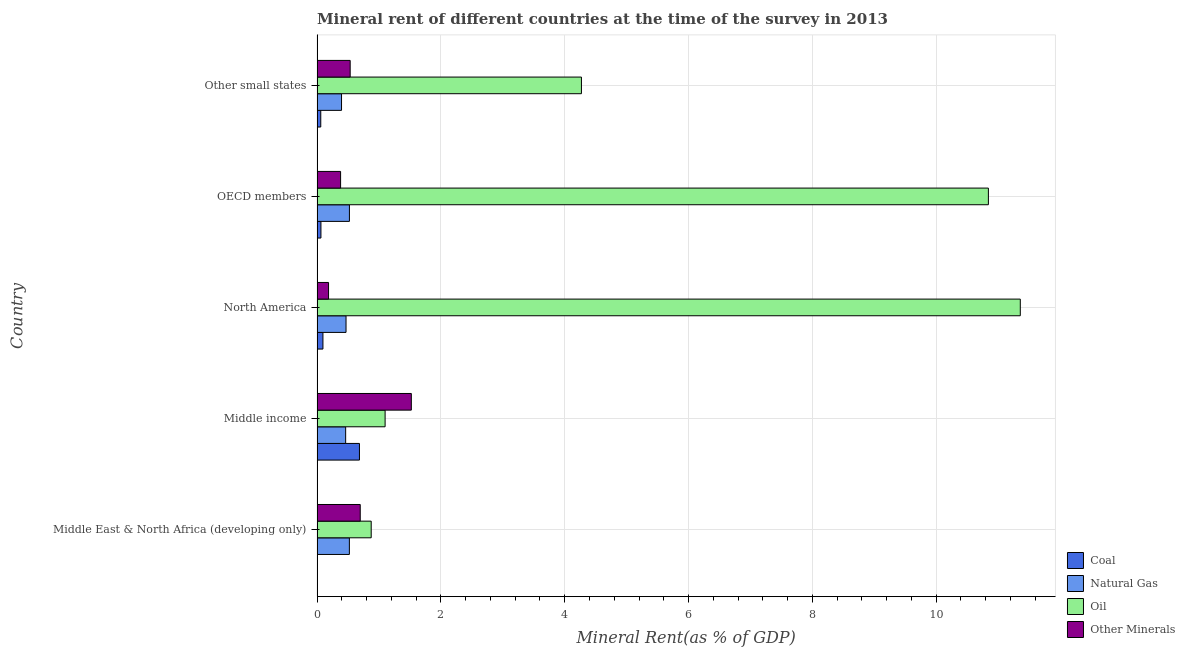How many groups of bars are there?
Ensure brevity in your answer.  5. How many bars are there on the 1st tick from the top?
Offer a terse response. 4. In how many cases, is the number of bars for a given country not equal to the number of legend labels?
Your answer should be compact. 0. What is the coal rent in North America?
Give a very brief answer. 0.09. Across all countries, what is the maximum oil rent?
Give a very brief answer. 11.36. Across all countries, what is the minimum  rent of other minerals?
Provide a short and direct response. 0.19. In which country was the oil rent maximum?
Offer a terse response. North America. In which country was the oil rent minimum?
Your answer should be very brief. Middle East & North Africa (developing only). What is the total natural gas rent in the graph?
Your response must be concise. 2.37. What is the difference between the  rent of other minerals in Middle East & North Africa (developing only) and that in North America?
Provide a short and direct response. 0.51. What is the difference between the oil rent in Middle income and the coal rent in OECD members?
Your response must be concise. 1.04. What is the average  rent of other minerals per country?
Offer a terse response. 0.66. What is the difference between the natural gas rent and oil rent in Middle income?
Keep it short and to the point. -0.64. In how many countries, is the oil rent greater than 4.8 %?
Your answer should be compact. 2. What is the ratio of the oil rent in North America to that in Other small states?
Provide a short and direct response. 2.66. Is the coal rent in Middle East & North Africa (developing only) less than that in OECD members?
Your answer should be compact. Yes. What is the difference between the highest and the second highest oil rent?
Your response must be concise. 0.52. What is the difference between the highest and the lowest  rent of other minerals?
Offer a terse response. 1.34. Is it the case that in every country, the sum of the coal rent and  rent of other minerals is greater than the sum of oil rent and natural gas rent?
Ensure brevity in your answer.  No. What does the 3rd bar from the top in Other small states represents?
Ensure brevity in your answer.  Natural Gas. What does the 2nd bar from the bottom in Other small states represents?
Offer a terse response. Natural Gas. Is it the case that in every country, the sum of the coal rent and natural gas rent is greater than the oil rent?
Offer a very short reply. No. How many bars are there?
Provide a succinct answer. 20. Does the graph contain grids?
Offer a terse response. Yes. Where does the legend appear in the graph?
Offer a terse response. Bottom right. What is the title of the graph?
Your answer should be compact. Mineral rent of different countries at the time of the survey in 2013. What is the label or title of the X-axis?
Ensure brevity in your answer.  Mineral Rent(as % of GDP). What is the Mineral Rent(as % of GDP) of Coal in Middle East & North Africa (developing only)?
Ensure brevity in your answer.  0. What is the Mineral Rent(as % of GDP) in Natural Gas in Middle East & North Africa (developing only)?
Make the answer very short. 0.52. What is the Mineral Rent(as % of GDP) of Oil in Middle East & North Africa (developing only)?
Offer a very short reply. 0.87. What is the Mineral Rent(as % of GDP) of Other Minerals in Middle East & North Africa (developing only)?
Ensure brevity in your answer.  0.7. What is the Mineral Rent(as % of GDP) in Coal in Middle income?
Ensure brevity in your answer.  0.68. What is the Mineral Rent(as % of GDP) in Natural Gas in Middle income?
Offer a very short reply. 0.46. What is the Mineral Rent(as % of GDP) in Oil in Middle income?
Keep it short and to the point. 1.1. What is the Mineral Rent(as % of GDP) in Other Minerals in Middle income?
Offer a terse response. 1.52. What is the Mineral Rent(as % of GDP) of Coal in North America?
Make the answer very short. 0.09. What is the Mineral Rent(as % of GDP) of Natural Gas in North America?
Offer a very short reply. 0.47. What is the Mineral Rent(as % of GDP) in Oil in North America?
Make the answer very short. 11.36. What is the Mineral Rent(as % of GDP) in Other Minerals in North America?
Make the answer very short. 0.19. What is the Mineral Rent(as % of GDP) in Coal in OECD members?
Your answer should be compact. 0.06. What is the Mineral Rent(as % of GDP) in Natural Gas in OECD members?
Your response must be concise. 0.52. What is the Mineral Rent(as % of GDP) of Oil in OECD members?
Your answer should be very brief. 10.84. What is the Mineral Rent(as % of GDP) in Other Minerals in OECD members?
Offer a very short reply. 0.38. What is the Mineral Rent(as % of GDP) of Coal in Other small states?
Your answer should be very brief. 0.06. What is the Mineral Rent(as % of GDP) of Natural Gas in Other small states?
Provide a succinct answer. 0.4. What is the Mineral Rent(as % of GDP) in Oil in Other small states?
Provide a succinct answer. 4.27. What is the Mineral Rent(as % of GDP) in Other Minerals in Other small states?
Give a very brief answer. 0.54. Across all countries, what is the maximum Mineral Rent(as % of GDP) in Coal?
Your response must be concise. 0.68. Across all countries, what is the maximum Mineral Rent(as % of GDP) of Natural Gas?
Offer a very short reply. 0.52. Across all countries, what is the maximum Mineral Rent(as % of GDP) of Oil?
Keep it short and to the point. 11.36. Across all countries, what is the maximum Mineral Rent(as % of GDP) of Other Minerals?
Give a very brief answer. 1.52. Across all countries, what is the minimum Mineral Rent(as % of GDP) of Coal?
Provide a short and direct response. 0. Across all countries, what is the minimum Mineral Rent(as % of GDP) in Natural Gas?
Your answer should be compact. 0.4. Across all countries, what is the minimum Mineral Rent(as % of GDP) of Oil?
Your response must be concise. 0.87. Across all countries, what is the minimum Mineral Rent(as % of GDP) in Other Minerals?
Make the answer very short. 0.19. What is the total Mineral Rent(as % of GDP) in Coal in the graph?
Your response must be concise. 0.91. What is the total Mineral Rent(as % of GDP) in Natural Gas in the graph?
Your answer should be very brief. 2.37. What is the total Mineral Rent(as % of GDP) in Oil in the graph?
Ensure brevity in your answer.  28.45. What is the total Mineral Rent(as % of GDP) in Other Minerals in the graph?
Keep it short and to the point. 3.32. What is the difference between the Mineral Rent(as % of GDP) of Coal in Middle East & North Africa (developing only) and that in Middle income?
Offer a very short reply. -0.68. What is the difference between the Mineral Rent(as % of GDP) in Natural Gas in Middle East & North Africa (developing only) and that in Middle income?
Provide a short and direct response. 0.06. What is the difference between the Mineral Rent(as % of GDP) in Oil in Middle East & North Africa (developing only) and that in Middle income?
Offer a very short reply. -0.22. What is the difference between the Mineral Rent(as % of GDP) in Other Minerals in Middle East & North Africa (developing only) and that in Middle income?
Offer a terse response. -0.83. What is the difference between the Mineral Rent(as % of GDP) in Coal in Middle East & North Africa (developing only) and that in North America?
Offer a very short reply. -0.09. What is the difference between the Mineral Rent(as % of GDP) of Natural Gas in Middle East & North Africa (developing only) and that in North America?
Offer a terse response. 0.05. What is the difference between the Mineral Rent(as % of GDP) in Oil in Middle East & North Africa (developing only) and that in North America?
Give a very brief answer. -10.48. What is the difference between the Mineral Rent(as % of GDP) of Other Minerals in Middle East & North Africa (developing only) and that in North America?
Keep it short and to the point. 0.51. What is the difference between the Mineral Rent(as % of GDP) in Coal in Middle East & North Africa (developing only) and that in OECD members?
Make the answer very short. -0.06. What is the difference between the Mineral Rent(as % of GDP) of Natural Gas in Middle East & North Africa (developing only) and that in OECD members?
Make the answer very short. -0. What is the difference between the Mineral Rent(as % of GDP) in Oil in Middle East & North Africa (developing only) and that in OECD members?
Keep it short and to the point. -9.97. What is the difference between the Mineral Rent(as % of GDP) in Other Minerals in Middle East & North Africa (developing only) and that in OECD members?
Ensure brevity in your answer.  0.32. What is the difference between the Mineral Rent(as % of GDP) of Coal in Middle East & North Africa (developing only) and that in Other small states?
Your answer should be compact. -0.06. What is the difference between the Mineral Rent(as % of GDP) of Natural Gas in Middle East & North Africa (developing only) and that in Other small states?
Ensure brevity in your answer.  0.13. What is the difference between the Mineral Rent(as % of GDP) of Oil in Middle East & North Africa (developing only) and that in Other small states?
Offer a very short reply. -3.4. What is the difference between the Mineral Rent(as % of GDP) of Other Minerals in Middle East & North Africa (developing only) and that in Other small states?
Provide a short and direct response. 0.16. What is the difference between the Mineral Rent(as % of GDP) in Coal in Middle income and that in North America?
Your response must be concise. 0.59. What is the difference between the Mineral Rent(as % of GDP) of Natural Gas in Middle income and that in North America?
Keep it short and to the point. -0.01. What is the difference between the Mineral Rent(as % of GDP) of Oil in Middle income and that in North America?
Your answer should be compact. -10.26. What is the difference between the Mineral Rent(as % of GDP) in Other Minerals in Middle income and that in North America?
Offer a terse response. 1.34. What is the difference between the Mineral Rent(as % of GDP) in Coal in Middle income and that in OECD members?
Offer a terse response. 0.62. What is the difference between the Mineral Rent(as % of GDP) of Natural Gas in Middle income and that in OECD members?
Offer a very short reply. -0.06. What is the difference between the Mineral Rent(as % of GDP) of Oil in Middle income and that in OECD members?
Make the answer very short. -9.74. What is the difference between the Mineral Rent(as % of GDP) in Other Minerals in Middle income and that in OECD members?
Keep it short and to the point. 1.14. What is the difference between the Mineral Rent(as % of GDP) in Coal in Middle income and that in Other small states?
Your response must be concise. 0.62. What is the difference between the Mineral Rent(as % of GDP) in Natural Gas in Middle income and that in Other small states?
Keep it short and to the point. 0.07. What is the difference between the Mineral Rent(as % of GDP) in Oil in Middle income and that in Other small states?
Your answer should be very brief. -3.17. What is the difference between the Mineral Rent(as % of GDP) of Other Minerals in Middle income and that in Other small states?
Ensure brevity in your answer.  0.99. What is the difference between the Mineral Rent(as % of GDP) in Coal in North America and that in OECD members?
Offer a very short reply. 0.03. What is the difference between the Mineral Rent(as % of GDP) of Natural Gas in North America and that in OECD members?
Provide a succinct answer. -0.05. What is the difference between the Mineral Rent(as % of GDP) in Oil in North America and that in OECD members?
Provide a succinct answer. 0.52. What is the difference between the Mineral Rent(as % of GDP) of Other Minerals in North America and that in OECD members?
Keep it short and to the point. -0.19. What is the difference between the Mineral Rent(as % of GDP) in Coal in North America and that in Other small states?
Your response must be concise. 0.04. What is the difference between the Mineral Rent(as % of GDP) of Natural Gas in North America and that in Other small states?
Ensure brevity in your answer.  0.07. What is the difference between the Mineral Rent(as % of GDP) of Oil in North America and that in Other small states?
Give a very brief answer. 7.09. What is the difference between the Mineral Rent(as % of GDP) in Other Minerals in North America and that in Other small states?
Offer a very short reply. -0.35. What is the difference between the Mineral Rent(as % of GDP) of Coal in OECD members and that in Other small states?
Your response must be concise. 0. What is the difference between the Mineral Rent(as % of GDP) in Natural Gas in OECD members and that in Other small states?
Your answer should be very brief. 0.13. What is the difference between the Mineral Rent(as % of GDP) of Oil in OECD members and that in Other small states?
Give a very brief answer. 6.57. What is the difference between the Mineral Rent(as % of GDP) in Other Minerals in OECD members and that in Other small states?
Provide a succinct answer. -0.15. What is the difference between the Mineral Rent(as % of GDP) of Coal in Middle East & North Africa (developing only) and the Mineral Rent(as % of GDP) of Natural Gas in Middle income?
Ensure brevity in your answer.  -0.46. What is the difference between the Mineral Rent(as % of GDP) of Coal in Middle East & North Africa (developing only) and the Mineral Rent(as % of GDP) of Oil in Middle income?
Keep it short and to the point. -1.1. What is the difference between the Mineral Rent(as % of GDP) of Coal in Middle East & North Africa (developing only) and the Mineral Rent(as % of GDP) of Other Minerals in Middle income?
Provide a short and direct response. -1.52. What is the difference between the Mineral Rent(as % of GDP) in Natural Gas in Middle East & North Africa (developing only) and the Mineral Rent(as % of GDP) in Oil in Middle income?
Your answer should be compact. -0.58. What is the difference between the Mineral Rent(as % of GDP) of Natural Gas in Middle East & North Africa (developing only) and the Mineral Rent(as % of GDP) of Other Minerals in Middle income?
Ensure brevity in your answer.  -1. What is the difference between the Mineral Rent(as % of GDP) in Oil in Middle East & North Africa (developing only) and the Mineral Rent(as % of GDP) in Other Minerals in Middle income?
Your answer should be compact. -0.65. What is the difference between the Mineral Rent(as % of GDP) of Coal in Middle East & North Africa (developing only) and the Mineral Rent(as % of GDP) of Natural Gas in North America?
Your response must be concise. -0.46. What is the difference between the Mineral Rent(as % of GDP) in Coal in Middle East & North Africa (developing only) and the Mineral Rent(as % of GDP) in Oil in North America?
Your answer should be compact. -11.35. What is the difference between the Mineral Rent(as % of GDP) of Coal in Middle East & North Africa (developing only) and the Mineral Rent(as % of GDP) of Other Minerals in North America?
Give a very brief answer. -0.18. What is the difference between the Mineral Rent(as % of GDP) of Natural Gas in Middle East & North Africa (developing only) and the Mineral Rent(as % of GDP) of Oil in North America?
Offer a very short reply. -10.84. What is the difference between the Mineral Rent(as % of GDP) of Natural Gas in Middle East & North Africa (developing only) and the Mineral Rent(as % of GDP) of Other Minerals in North America?
Offer a terse response. 0.34. What is the difference between the Mineral Rent(as % of GDP) of Oil in Middle East & North Africa (developing only) and the Mineral Rent(as % of GDP) of Other Minerals in North America?
Make the answer very short. 0.69. What is the difference between the Mineral Rent(as % of GDP) of Coal in Middle East & North Africa (developing only) and the Mineral Rent(as % of GDP) of Natural Gas in OECD members?
Provide a succinct answer. -0.52. What is the difference between the Mineral Rent(as % of GDP) of Coal in Middle East & North Africa (developing only) and the Mineral Rent(as % of GDP) of Oil in OECD members?
Provide a succinct answer. -10.84. What is the difference between the Mineral Rent(as % of GDP) of Coal in Middle East & North Africa (developing only) and the Mineral Rent(as % of GDP) of Other Minerals in OECD members?
Provide a short and direct response. -0.38. What is the difference between the Mineral Rent(as % of GDP) in Natural Gas in Middle East & North Africa (developing only) and the Mineral Rent(as % of GDP) in Oil in OECD members?
Provide a succinct answer. -10.32. What is the difference between the Mineral Rent(as % of GDP) in Natural Gas in Middle East & North Africa (developing only) and the Mineral Rent(as % of GDP) in Other Minerals in OECD members?
Offer a very short reply. 0.14. What is the difference between the Mineral Rent(as % of GDP) of Oil in Middle East & North Africa (developing only) and the Mineral Rent(as % of GDP) of Other Minerals in OECD members?
Offer a very short reply. 0.49. What is the difference between the Mineral Rent(as % of GDP) of Coal in Middle East & North Africa (developing only) and the Mineral Rent(as % of GDP) of Natural Gas in Other small states?
Your answer should be compact. -0.39. What is the difference between the Mineral Rent(as % of GDP) of Coal in Middle East & North Africa (developing only) and the Mineral Rent(as % of GDP) of Oil in Other small states?
Ensure brevity in your answer.  -4.27. What is the difference between the Mineral Rent(as % of GDP) in Coal in Middle East & North Africa (developing only) and the Mineral Rent(as % of GDP) in Other Minerals in Other small states?
Keep it short and to the point. -0.53. What is the difference between the Mineral Rent(as % of GDP) of Natural Gas in Middle East & North Africa (developing only) and the Mineral Rent(as % of GDP) of Oil in Other small states?
Your answer should be compact. -3.75. What is the difference between the Mineral Rent(as % of GDP) of Natural Gas in Middle East & North Africa (developing only) and the Mineral Rent(as % of GDP) of Other Minerals in Other small states?
Offer a terse response. -0.01. What is the difference between the Mineral Rent(as % of GDP) in Oil in Middle East & North Africa (developing only) and the Mineral Rent(as % of GDP) in Other Minerals in Other small states?
Offer a terse response. 0.34. What is the difference between the Mineral Rent(as % of GDP) in Coal in Middle income and the Mineral Rent(as % of GDP) in Natural Gas in North America?
Your answer should be compact. 0.22. What is the difference between the Mineral Rent(as % of GDP) in Coal in Middle income and the Mineral Rent(as % of GDP) in Oil in North America?
Provide a short and direct response. -10.67. What is the difference between the Mineral Rent(as % of GDP) of Coal in Middle income and the Mineral Rent(as % of GDP) of Other Minerals in North America?
Make the answer very short. 0.5. What is the difference between the Mineral Rent(as % of GDP) of Natural Gas in Middle income and the Mineral Rent(as % of GDP) of Oil in North America?
Offer a terse response. -10.9. What is the difference between the Mineral Rent(as % of GDP) of Natural Gas in Middle income and the Mineral Rent(as % of GDP) of Other Minerals in North America?
Provide a short and direct response. 0.28. What is the difference between the Mineral Rent(as % of GDP) in Oil in Middle income and the Mineral Rent(as % of GDP) in Other Minerals in North America?
Provide a short and direct response. 0.91. What is the difference between the Mineral Rent(as % of GDP) in Coal in Middle income and the Mineral Rent(as % of GDP) in Natural Gas in OECD members?
Provide a short and direct response. 0.16. What is the difference between the Mineral Rent(as % of GDP) in Coal in Middle income and the Mineral Rent(as % of GDP) in Oil in OECD members?
Give a very brief answer. -10.16. What is the difference between the Mineral Rent(as % of GDP) in Coal in Middle income and the Mineral Rent(as % of GDP) in Other Minerals in OECD members?
Give a very brief answer. 0.3. What is the difference between the Mineral Rent(as % of GDP) of Natural Gas in Middle income and the Mineral Rent(as % of GDP) of Oil in OECD members?
Ensure brevity in your answer.  -10.38. What is the difference between the Mineral Rent(as % of GDP) of Natural Gas in Middle income and the Mineral Rent(as % of GDP) of Other Minerals in OECD members?
Provide a short and direct response. 0.08. What is the difference between the Mineral Rent(as % of GDP) of Oil in Middle income and the Mineral Rent(as % of GDP) of Other Minerals in OECD members?
Give a very brief answer. 0.72. What is the difference between the Mineral Rent(as % of GDP) of Coal in Middle income and the Mineral Rent(as % of GDP) of Natural Gas in Other small states?
Provide a short and direct response. 0.29. What is the difference between the Mineral Rent(as % of GDP) of Coal in Middle income and the Mineral Rent(as % of GDP) of Oil in Other small states?
Offer a terse response. -3.59. What is the difference between the Mineral Rent(as % of GDP) in Coal in Middle income and the Mineral Rent(as % of GDP) in Other Minerals in Other small states?
Offer a very short reply. 0.15. What is the difference between the Mineral Rent(as % of GDP) in Natural Gas in Middle income and the Mineral Rent(as % of GDP) in Oil in Other small states?
Your answer should be very brief. -3.81. What is the difference between the Mineral Rent(as % of GDP) of Natural Gas in Middle income and the Mineral Rent(as % of GDP) of Other Minerals in Other small states?
Your response must be concise. -0.07. What is the difference between the Mineral Rent(as % of GDP) in Oil in Middle income and the Mineral Rent(as % of GDP) in Other Minerals in Other small states?
Offer a terse response. 0.56. What is the difference between the Mineral Rent(as % of GDP) in Coal in North America and the Mineral Rent(as % of GDP) in Natural Gas in OECD members?
Ensure brevity in your answer.  -0.43. What is the difference between the Mineral Rent(as % of GDP) of Coal in North America and the Mineral Rent(as % of GDP) of Oil in OECD members?
Offer a terse response. -10.75. What is the difference between the Mineral Rent(as % of GDP) in Coal in North America and the Mineral Rent(as % of GDP) in Other Minerals in OECD members?
Your answer should be compact. -0.29. What is the difference between the Mineral Rent(as % of GDP) of Natural Gas in North America and the Mineral Rent(as % of GDP) of Oil in OECD members?
Your answer should be compact. -10.38. What is the difference between the Mineral Rent(as % of GDP) of Natural Gas in North America and the Mineral Rent(as % of GDP) of Other Minerals in OECD members?
Provide a short and direct response. 0.09. What is the difference between the Mineral Rent(as % of GDP) of Oil in North America and the Mineral Rent(as % of GDP) of Other Minerals in OECD members?
Offer a very short reply. 10.98. What is the difference between the Mineral Rent(as % of GDP) in Coal in North America and the Mineral Rent(as % of GDP) in Natural Gas in Other small states?
Keep it short and to the point. -0.3. What is the difference between the Mineral Rent(as % of GDP) of Coal in North America and the Mineral Rent(as % of GDP) of Oil in Other small states?
Your answer should be very brief. -4.18. What is the difference between the Mineral Rent(as % of GDP) of Coal in North America and the Mineral Rent(as % of GDP) of Other Minerals in Other small states?
Give a very brief answer. -0.44. What is the difference between the Mineral Rent(as % of GDP) of Natural Gas in North America and the Mineral Rent(as % of GDP) of Oil in Other small states?
Keep it short and to the point. -3.8. What is the difference between the Mineral Rent(as % of GDP) of Natural Gas in North America and the Mineral Rent(as % of GDP) of Other Minerals in Other small states?
Provide a short and direct response. -0.07. What is the difference between the Mineral Rent(as % of GDP) of Oil in North America and the Mineral Rent(as % of GDP) of Other Minerals in Other small states?
Give a very brief answer. 10.82. What is the difference between the Mineral Rent(as % of GDP) of Coal in OECD members and the Mineral Rent(as % of GDP) of Natural Gas in Other small states?
Your answer should be compact. -0.33. What is the difference between the Mineral Rent(as % of GDP) in Coal in OECD members and the Mineral Rent(as % of GDP) in Oil in Other small states?
Make the answer very short. -4.21. What is the difference between the Mineral Rent(as % of GDP) in Coal in OECD members and the Mineral Rent(as % of GDP) in Other Minerals in Other small states?
Your answer should be very brief. -0.47. What is the difference between the Mineral Rent(as % of GDP) in Natural Gas in OECD members and the Mineral Rent(as % of GDP) in Oil in Other small states?
Provide a succinct answer. -3.75. What is the difference between the Mineral Rent(as % of GDP) of Natural Gas in OECD members and the Mineral Rent(as % of GDP) of Other Minerals in Other small states?
Keep it short and to the point. -0.01. What is the difference between the Mineral Rent(as % of GDP) in Oil in OECD members and the Mineral Rent(as % of GDP) in Other Minerals in Other small states?
Make the answer very short. 10.31. What is the average Mineral Rent(as % of GDP) of Coal per country?
Ensure brevity in your answer.  0.18. What is the average Mineral Rent(as % of GDP) of Natural Gas per country?
Give a very brief answer. 0.47. What is the average Mineral Rent(as % of GDP) of Oil per country?
Give a very brief answer. 5.69. What is the average Mineral Rent(as % of GDP) in Other Minerals per country?
Ensure brevity in your answer.  0.66. What is the difference between the Mineral Rent(as % of GDP) of Coal and Mineral Rent(as % of GDP) of Natural Gas in Middle East & North Africa (developing only)?
Give a very brief answer. -0.52. What is the difference between the Mineral Rent(as % of GDP) of Coal and Mineral Rent(as % of GDP) of Oil in Middle East & North Africa (developing only)?
Make the answer very short. -0.87. What is the difference between the Mineral Rent(as % of GDP) of Coal and Mineral Rent(as % of GDP) of Other Minerals in Middle East & North Africa (developing only)?
Offer a very short reply. -0.69. What is the difference between the Mineral Rent(as % of GDP) in Natural Gas and Mineral Rent(as % of GDP) in Oil in Middle East & North Africa (developing only)?
Keep it short and to the point. -0.35. What is the difference between the Mineral Rent(as % of GDP) of Natural Gas and Mineral Rent(as % of GDP) of Other Minerals in Middle East & North Africa (developing only)?
Offer a terse response. -0.18. What is the difference between the Mineral Rent(as % of GDP) of Oil and Mineral Rent(as % of GDP) of Other Minerals in Middle East & North Africa (developing only)?
Keep it short and to the point. 0.18. What is the difference between the Mineral Rent(as % of GDP) in Coal and Mineral Rent(as % of GDP) in Natural Gas in Middle income?
Your response must be concise. 0.22. What is the difference between the Mineral Rent(as % of GDP) in Coal and Mineral Rent(as % of GDP) in Oil in Middle income?
Offer a terse response. -0.41. What is the difference between the Mineral Rent(as % of GDP) of Coal and Mineral Rent(as % of GDP) of Other Minerals in Middle income?
Offer a very short reply. -0.84. What is the difference between the Mineral Rent(as % of GDP) in Natural Gas and Mineral Rent(as % of GDP) in Oil in Middle income?
Your response must be concise. -0.64. What is the difference between the Mineral Rent(as % of GDP) in Natural Gas and Mineral Rent(as % of GDP) in Other Minerals in Middle income?
Make the answer very short. -1.06. What is the difference between the Mineral Rent(as % of GDP) of Oil and Mineral Rent(as % of GDP) of Other Minerals in Middle income?
Make the answer very short. -0.42. What is the difference between the Mineral Rent(as % of GDP) in Coal and Mineral Rent(as % of GDP) in Natural Gas in North America?
Give a very brief answer. -0.37. What is the difference between the Mineral Rent(as % of GDP) in Coal and Mineral Rent(as % of GDP) in Oil in North America?
Make the answer very short. -11.26. What is the difference between the Mineral Rent(as % of GDP) of Coal and Mineral Rent(as % of GDP) of Other Minerals in North America?
Offer a very short reply. -0.09. What is the difference between the Mineral Rent(as % of GDP) of Natural Gas and Mineral Rent(as % of GDP) of Oil in North America?
Your response must be concise. -10.89. What is the difference between the Mineral Rent(as % of GDP) in Natural Gas and Mineral Rent(as % of GDP) in Other Minerals in North America?
Keep it short and to the point. 0.28. What is the difference between the Mineral Rent(as % of GDP) of Oil and Mineral Rent(as % of GDP) of Other Minerals in North America?
Offer a terse response. 11.17. What is the difference between the Mineral Rent(as % of GDP) of Coal and Mineral Rent(as % of GDP) of Natural Gas in OECD members?
Offer a very short reply. -0.46. What is the difference between the Mineral Rent(as % of GDP) in Coal and Mineral Rent(as % of GDP) in Oil in OECD members?
Your answer should be compact. -10.78. What is the difference between the Mineral Rent(as % of GDP) of Coal and Mineral Rent(as % of GDP) of Other Minerals in OECD members?
Make the answer very short. -0.32. What is the difference between the Mineral Rent(as % of GDP) in Natural Gas and Mineral Rent(as % of GDP) in Oil in OECD members?
Provide a succinct answer. -10.32. What is the difference between the Mineral Rent(as % of GDP) of Natural Gas and Mineral Rent(as % of GDP) of Other Minerals in OECD members?
Give a very brief answer. 0.14. What is the difference between the Mineral Rent(as % of GDP) in Oil and Mineral Rent(as % of GDP) in Other Minerals in OECD members?
Your answer should be very brief. 10.46. What is the difference between the Mineral Rent(as % of GDP) in Coal and Mineral Rent(as % of GDP) in Natural Gas in Other small states?
Ensure brevity in your answer.  -0.34. What is the difference between the Mineral Rent(as % of GDP) in Coal and Mineral Rent(as % of GDP) in Oil in Other small states?
Your response must be concise. -4.21. What is the difference between the Mineral Rent(as % of GDP) of Coal and Mineral Rent(as % of GDP) of Other Minerals in Other small states?
Give a very brief answer. -0.48. What is the difference between the Mineral Rent(as % of GDP) of Natural Gas and Mineral Rent(as % of GDP) of Oil in Other small states?
Provide a succinct answer. -3.87. What is the difference between the Mineral Rent(as % of GDP) of Natural Gas and Mineral Rent(as % of GDP) of Other Minerals in Other small states?
Ensure brevity in your answer.  -0.14. What is the difference between the Mineral Rent(as % of GDP) of Oil and Mineral Rent(as % of GDP) of Other Minerals in Other small states?
Your answer should be compact. 3.74. What is the ratio of the Mineral Rent(as % of GDP) of Coal in Middle East & North Africa (developing only) to that in Middle income?
Offer a terse response. 0.01. What is the ratio of the Mineral Rent(as % of GDP) of Natural Gas in Middle East & North Africa (developing only) to that in Middle income?
Ensure brevity in your answer.  1.13. What is the ratio of the Mineral Rent(as % of GDP) in Oil in Middle East & North Africa (developing only) to that in Middle income?
Provide a succinct answer. 0.8. What is the ratio of the Mineral Rent(as % of GDP) in Other Minerals in Middle East & North Africa (developing only) to that in Middle income?
Make the answer very short. 0.46. What is the ratio of the Mineral Rent(as % of GDP) in Coal in Middle East & North Africa (developing only) to that in North America?
Offer a terse response. 0.04. What is the ratio of the Mineral Rent(as % of GDP) in Natural Gas in Middle East & North Africa (developing only) to that in North America?
Your answer should be compact. 1.12. What is the ratio of the Mineral Rent(as % of GDP) in Oil in Middle East & North Africa (developing only) to that in North America?
Offer a terse response. 0.08. What is the ratio of the Mineral Rent(as % of GDP) of Other Minerals in Middle East & North Africa (developing only) to that in North America?
Make the answer very short. 3.76. What is the ratio of the Mineral Rent(as % of GDP) of Coal in Middle East & North Africa (developing only) to that in OECD members?
Give a very brief answer. 0.06. What is the ratio of the Mineral Rent(as % of GDP) in Oil in Middle East & North Africa (developing only) to that in OECD members?
Offer a very short reply. 0.08. What is the ratio of the Mineral Rent(as % of GDP) of Other Minerals in Middle East & North Africa (developing only) to that in OECD members?
Your answer should be very brief. 1.83. What is the ratio of the Mineral Rent(as % of GDP) in Coal in Middle East & North Africa (developing only) to that in Other small states?
Your answer should be compact. 0.07. What is the ratio of the Mineral Rent(as % of GDP) in Natural Gas in Middle East & North Africa (developing only) to that in Other small states?
Ensure brevity in your answer.  1.32. What is the ratio of the Mineral Rent(as % of GDP) in Oil in Middle East & North Africa (developing only) to that in Other small states?
Keep it short and to the point. 0.2. What is the ratio of the Mineral Rent(as % of GDP) of Other Minerals in Middle East & North Africa (developing only) to that in Other small states?
Provide a short and direct response. 1.3. What is the ratio of the Mineral Rent(as % of GDP) of Coal in Middle income to that in North America?
Your answer should be compact. 7.21. What is the ratio of the Mineral Rent(as % of GDP) in Natural Gas in Middle income to that in North America?
Ensure brevity in your answer.  0.99. What is the ratio of the Mineral Rent(as % of GDP) of Oil in Middle income to that in North America?
Provide a short and direct response. 0.1. What is the ratio of the Mineral Rent(as % of GDP) of Other Minerals in Middle income to that in North America?
Offer a terse response. 8.2. What is the ratio of the Mineral Rent(as % of GDP) of Coal in Middle income to that in OECD members?
Offer a very short reply. 10.89. What is the ratio of the Mineral Rent(as % of GDP) in Natural Gas in Middle income to that in OECD members?
Keep it short and to the point. 0.88. What is the ratio of the Mineral Rent(as % of GDP) of Oil in Middle income to that in OECD members?
Offer a very short reply. 0.1. What is the ratio of the Mineral Rent(as % of GDP) in Other Minerals in Middle income to that in OECD members?
Ensure brevity in your answer.  4. What is the ratio of the Mineral Rent(as % of GDP) in Coal in Middle income to that in Other small states?
Your answer should be compact. 11.43. What is the ratio of the Mineral Rent(as % of GDP) in Natural Gas in Middle income to that in Other small states?
Make the answer very short. 1.17. What is the ratio of the Mineral Rent(as % of GDP) in Oil in Middle income to that in Other small states?
Make the answer very short. 0.26. What is the ratio of the Mineral Rent(as % of GDP) in Other Minerals in Middle income to that in Other small states?
Make the answer very short. 2.85. What is the ratio of the Mineral Rent(as % of GDP) of Coal in North America to that in OECD members?
Offer a very short reply. 1.51. What is the ratio of the Mineral Rent(as % of GDP) in Natural Gas in North America to that in OECD members?
Offer a very short reply. 0.9. What is the ratio of the Mineral Rent(as % of GDP) in Oil in North America to that in OECD members?
Ensure brevity in your answer.  1.05. What is the ratio of the Mineral Rent(as % of GDP) in Other Minerals in North America to that in OECD members?
Offer a very short reply. 0.49. What is the ratio of the Mineral Rent(as % of GDP) of Coal in North America to that in Other small states?
Ensure brevity in your answer.  1.59. What is the ratio of the Mineral Rent(as % of GDP) in Natural Gas in North America to that in Other small states?
Make the answer very short. 1.18. What is the ratio of the Mineral Rent(as % of GDP) in Oil in North America to that in Other small states?
Ensure brevity in your answer.  2.66. What is the ratio of the Mineral Rent(as % of GDP) of Other Minerals in North America to that in Other small states?
Your answer should be compact. 0.35. What is the ratio of the Mineral Rent(as % of GDP) in Coal in OECD members to that in Other small states?
Ensure brevity in your answer.  1.05. What is the ratio of the Mineral Rent(as % of GDP) in Natural Gas in OECD members to that in Other small states?
Your response must be concise. 1.32. What is the ratio of the Mineral Rent(as % of GDP) of Oil in OECD members to that in Other small states?
Make the answer very short. 2.54. What is the ratio of the Mineral Rent(as % of GDP) of Other Minerals in OECD members to that in Other small states?
Make the answer very short. 0.71. What is the difference between the highest and the second highest Mineral Rent(as % of GDP) in Coal?
Offer a terse response. 0.59. What is the difference between the highest and the second highest Mineral Rent(as % of GDP) of Natural Gas?
Make the answer very short. 0. What is the difference between the highest and the second highest Mineral Rent(as % of GDP) in Oil?
Provide a short and direct response. 0.52. What is the difference between the highest and the second highest Mineral Rent(as % of GDP) in Other Minerals?
Keep it short and to the point. 0.83. What is the difference between the highest and the lowest Mineral Rent(as % of GDP) of Coal?
Your answer should be very brief. 0.68. What is the difference between the highest and the lowest Mineral Rent(as % of GDP) of Natural Gas?
Ensure brevity in your answer.  0.13. What is the difference between the highest and the lowest Mineral Rent(as % of GDP) of Oil?
Give a very brief answer. 10.48. What is the difference between the highest and the lowest Mineral Rent(as % of GDP) of Other Minerals?
Make the answer very short. 1.34. 